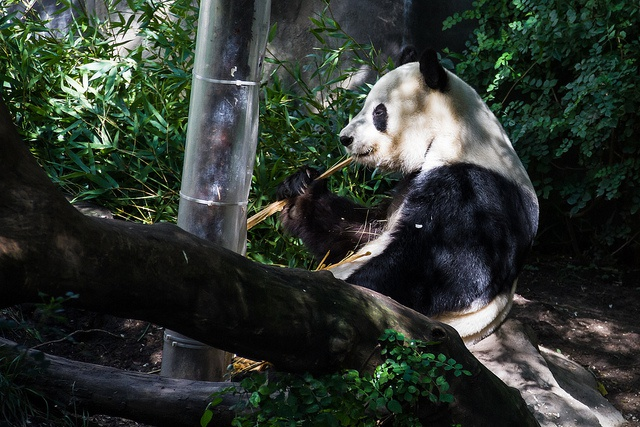Describe the objects in this image and their specific colors. I can see a bear in lightgray, black, gray, and darkgray tones in this image. 